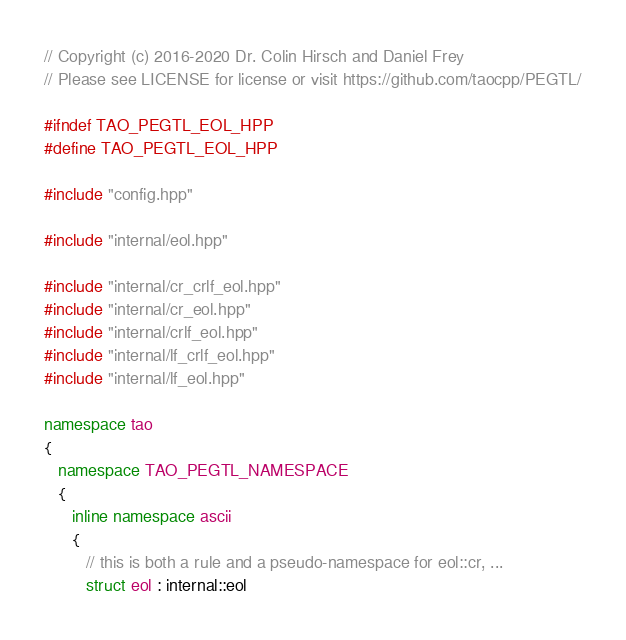Convert code to text. <code><loc_0><loc_0><loc_500><loc_500><_C++_>// Copyright (c) 2016-2020 Dr. Colin Hirsch and Daniel Frey
// Please see LICENSE for license or visit https://github.com/taocpp/PEGTL/

#ifndef TAO_PEGTL_EOL_HPP
#define TAO_PEGTL_EOL_HPP

#include "config.hpp"

#include "internal/eol.hpp"

#include "internal/cr_crlf_eol.hpp"
#include "internal/cr_eol.hpp"
#include "internal/crlf_eol.hpp"
#include "internal/lf_crlf_eol.hpp"
#include "internal/lf_eol.hpp"

namespace tao
{
   namespace TAO_PEGTL_NAMESPACE
   {
      inline namespace ascii
      {
         // this is both a rule and a pseudo-namespace for eol::cr, ...
         struct eol : internal::eol</code> 